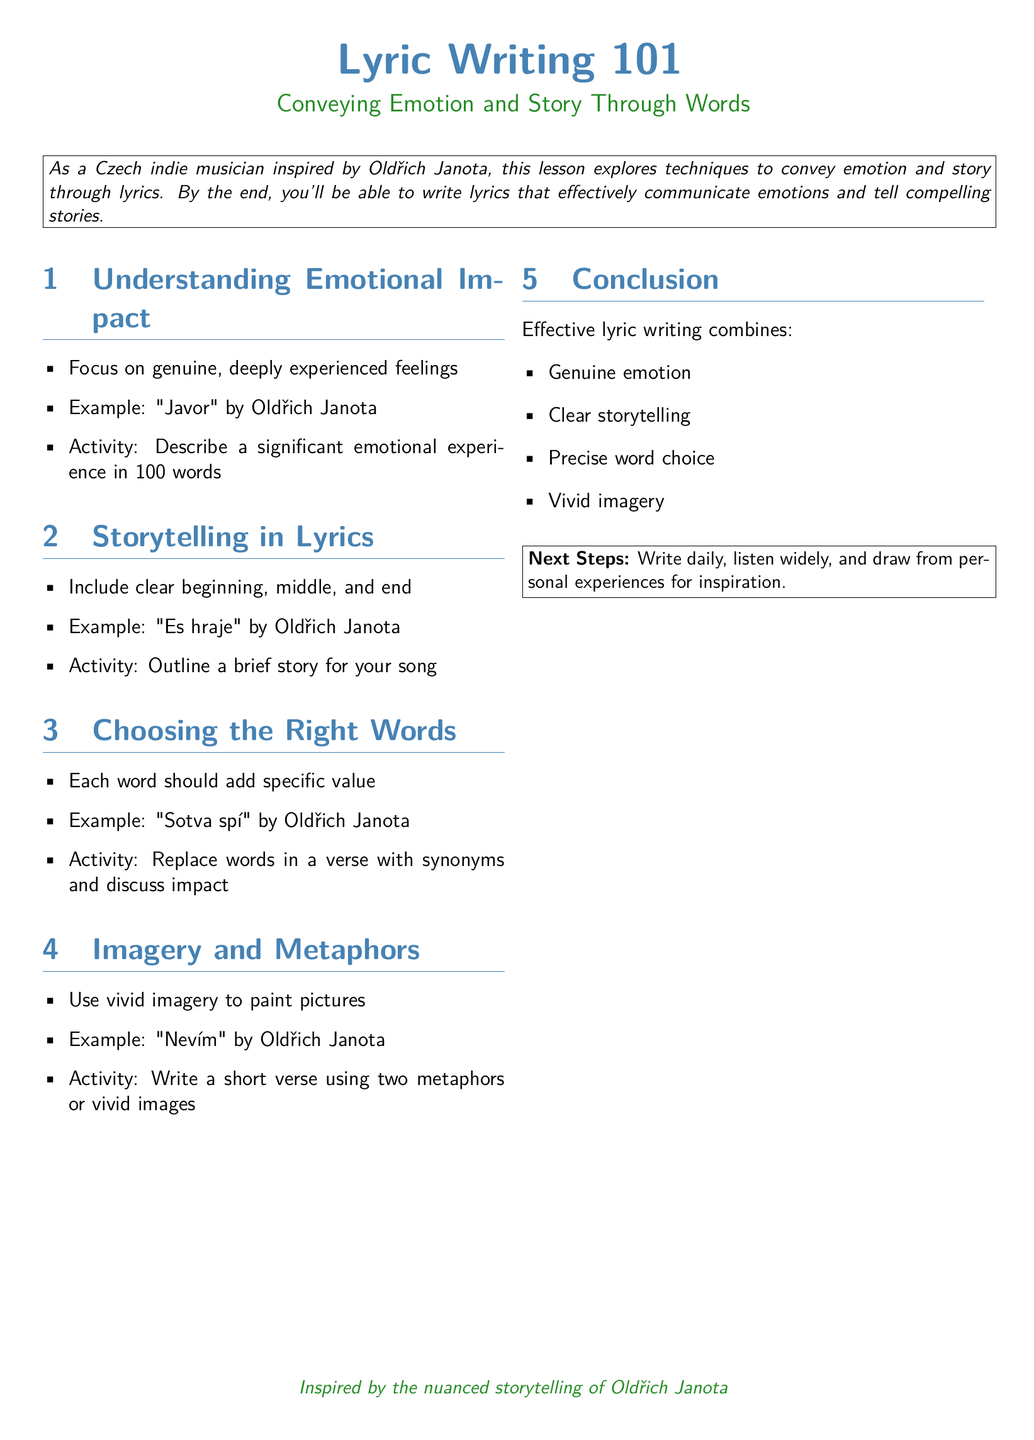What is the title of the lesson plan? The title of the lesson plan is prominently displayed at the beginning of the document.
Answer: Lyric Writing 101 What is the main focus of the lesson? The main focus is indicated in the subtitle, highlighting the central theme of the lesson.
Answer: Conveying Emotion and Story Through Words Which artist's work is used as an example for understanding emotional impact? The document cites specific examples from a known artist to illustrate concepts in the lesson.
Answer: Oldřich Janota What activity is suggested for understanding emotional impact? The document outlines an activity to reinforce the teaching points within the section.
Answer: Describe a significant emotional experience in 100 words What are the four key components of effective lyric writing listed in the conclusion? The conclusion summarizes the essential elements discussed throughout the lesson.
Answer: Genuine emotion, Clear storytelling, Precise word choice, Vivid imagery How many sections are there in the document? The sections are numbered, providing a clear structure to the lesson.
Answer: Four Which song by Oldřich Janota is an example for choosing the right words? One specific song is referenced to illustrate the concept of word choice.
Answer: Sotva spí What does the lesson suggest as next steps for participants? The document provides actionable advice in the final box for readers to continue their development.
Answer: Write daily, listen widely, and draw from personal experiences for inspiration 